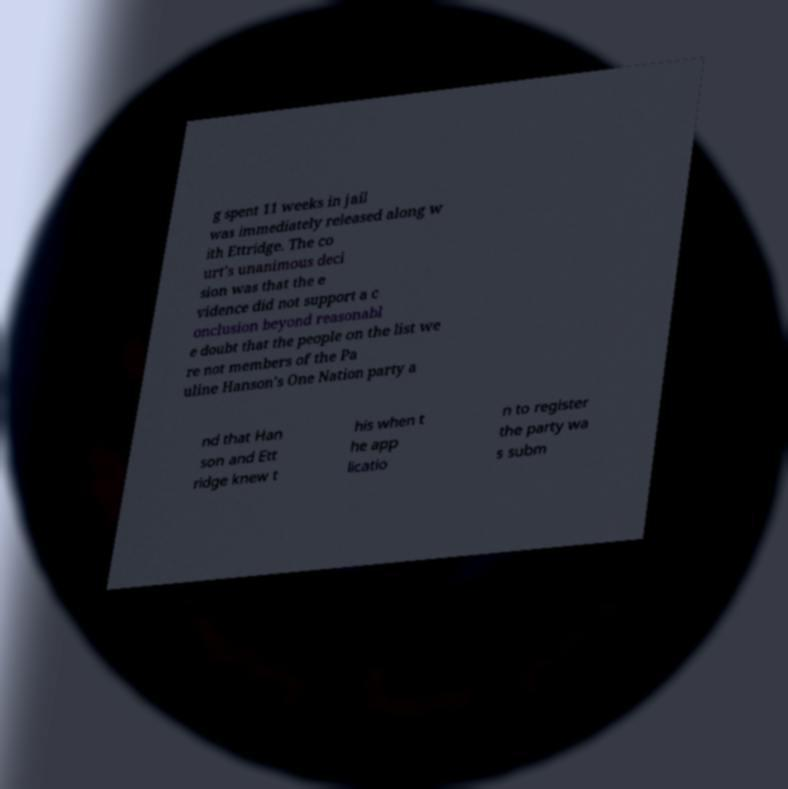There's text embedded in this image that I need extracted. Can you transcribe it verbatim? g spent 11 weeks in jail was immediately released along w ith Ettridge. The co urt's unanimous deci sion was that the e vidence did not support a c onclusion beyond reasonabl e doubt that the people on the list we re not members of the Pa uline Hanson's One Nation party a nd that Han son and Ett ridge knew t his when t he app licatio n to register the party wa s subm 